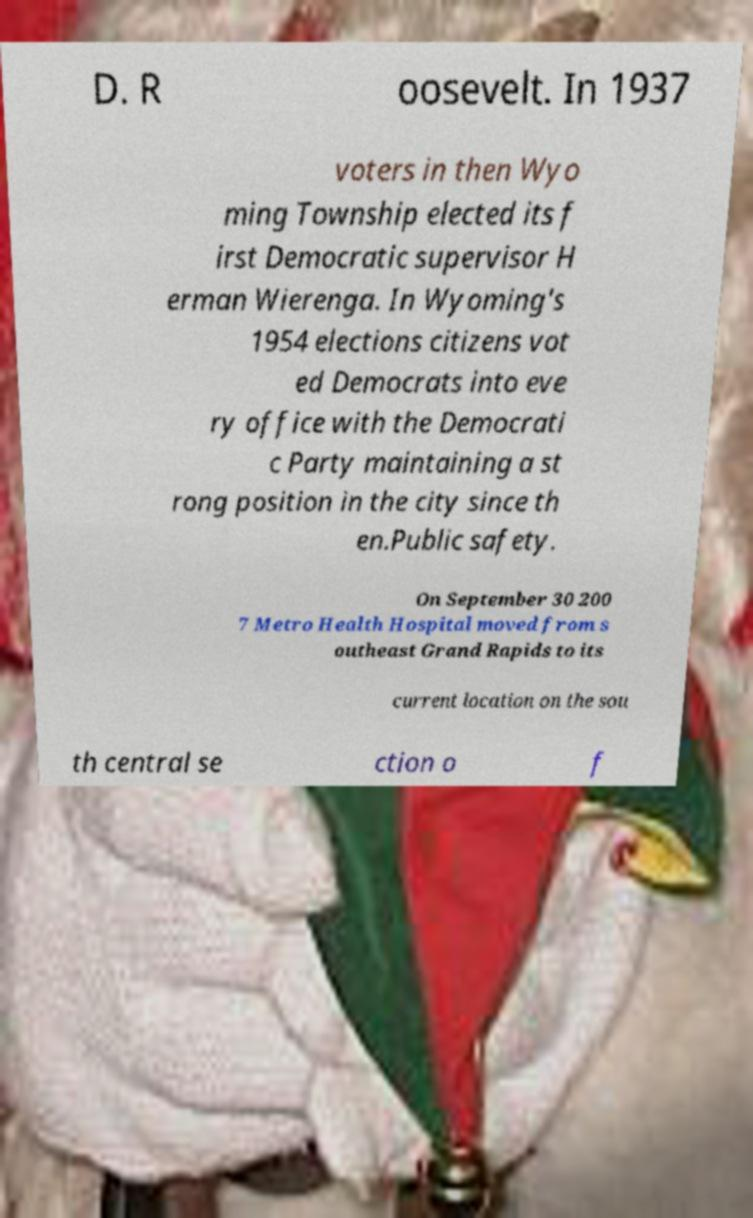Please read and relay the text visible in this image. What does it say? D. R oosevelt. In 1937 voters in then Wyo ming Township elected its f irst Democratic supervisor H erman Wierenga. In Wyoming's 1954 elections citizens vot ed Democrats into eve ry office with the Democrati c Party maintaining a st rong position in the city since th en.Public safety. On September 30 200 7 Metro Health Hospital moved from s outheast Grand Rapids to its current location on the sou th central se ction o f 